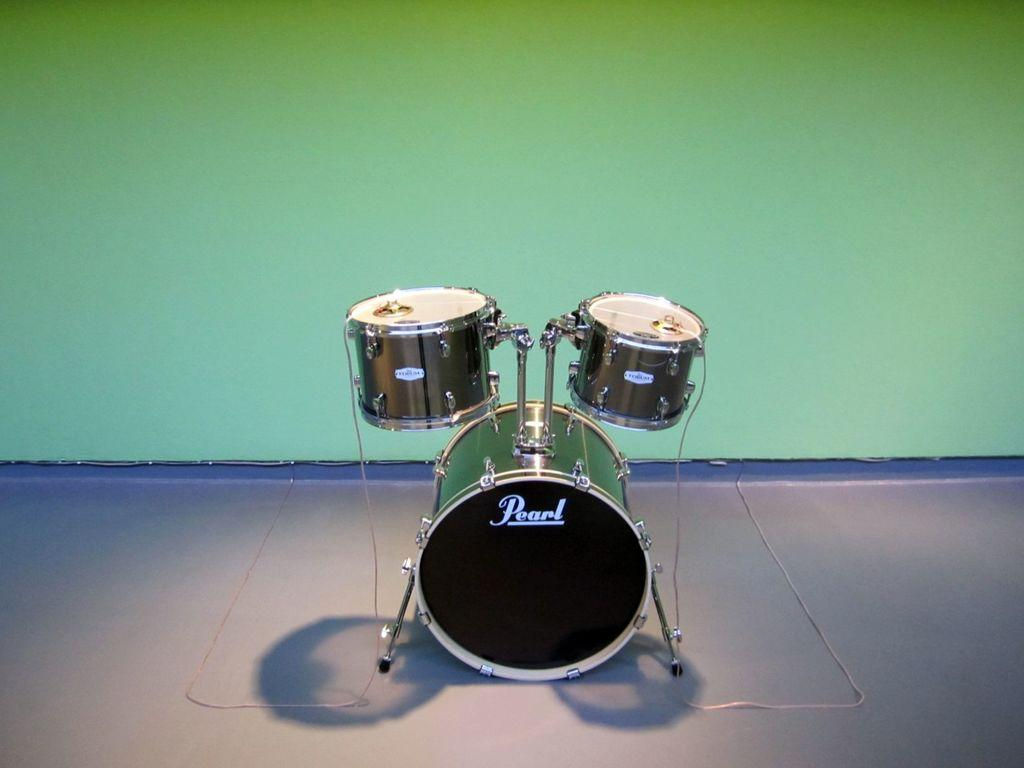What musical instruments are present in the image? There are drums in the image. What color is the background of the image? The background of the image is green in color. How many stamps are visible on the drums in the image? There are no stamps visible on the drums in the image. What type of architectural structure can be seen in the background of the image? There is no architectural structure visible in the background of the image; it is green in color. 